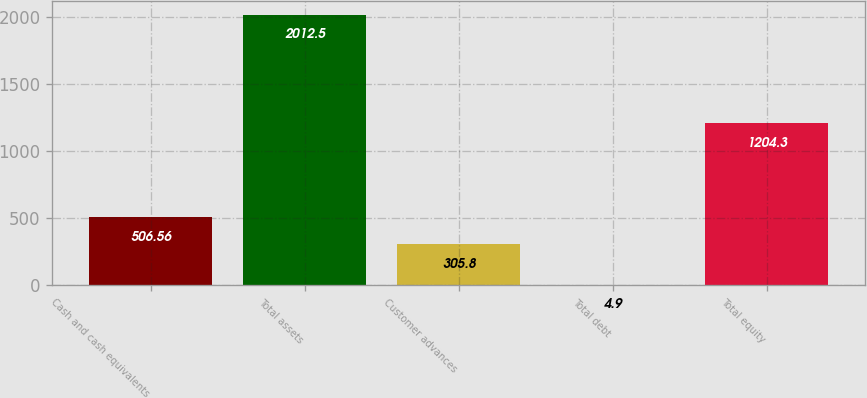<chart> <loc_0><loc_0><loc_500><loc_500><bar_chart><fcel>Cash and cash equivalents<fcel>Total assets<fcel>Customer advances<fcel>Total debt<fcel>Total equity<nl><fcel>506.56<fcel>2012.5<fcel>305.8<fcel>4.9<fcel>1204.3<nl></chart> 